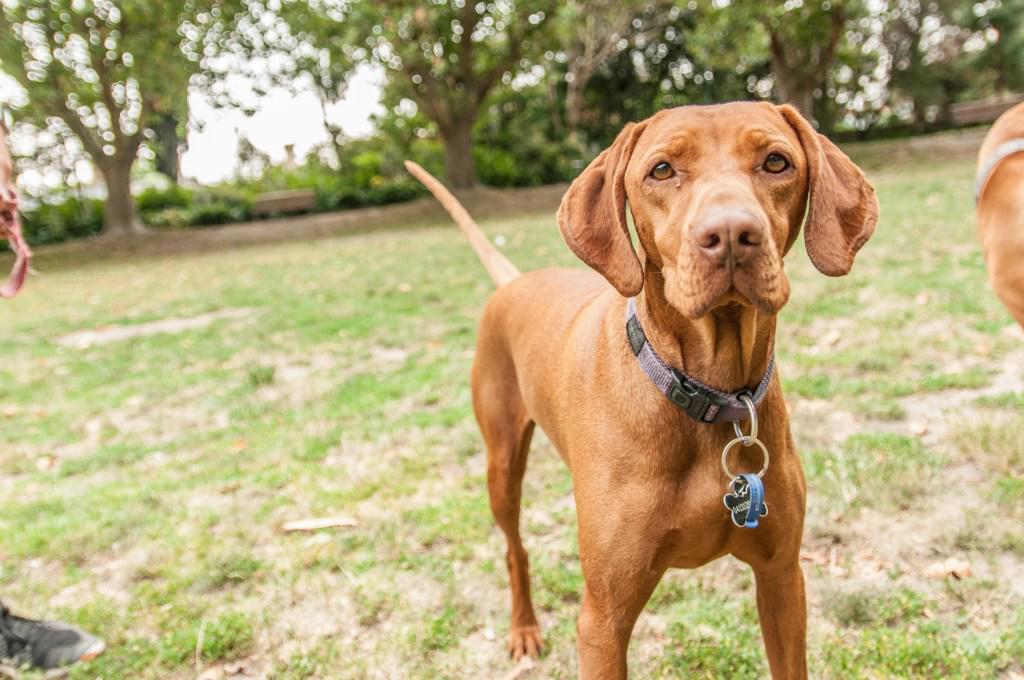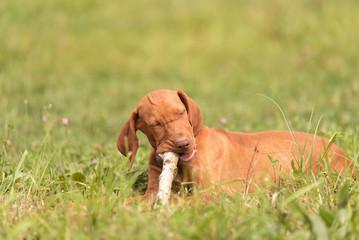The first image is the image on the left, the second image is the image on the right. Analyze the images presented: Is the assertion "One dog is laying down." valid? Answer yes or no. Yes. The first image is the image on the left, the second image is the image on the right. Given the left and right images, does the statement "In total, two dogs are outdoors with a wooden stick grasped in their mouth." hold true? Answer yes or no. No. 